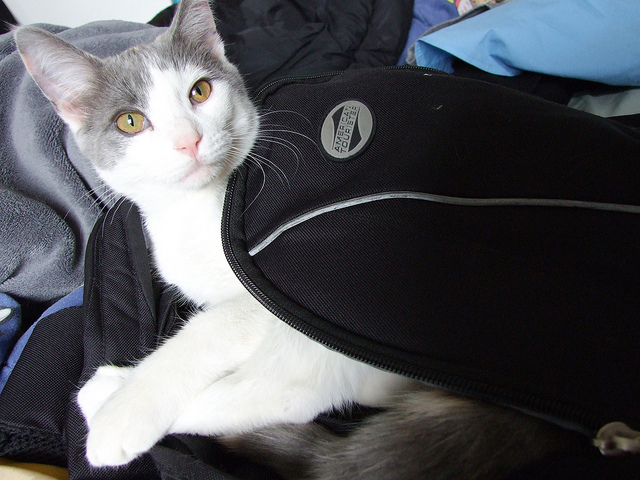Extract all visible text content from this image. AMERICAN TOURISTERS 